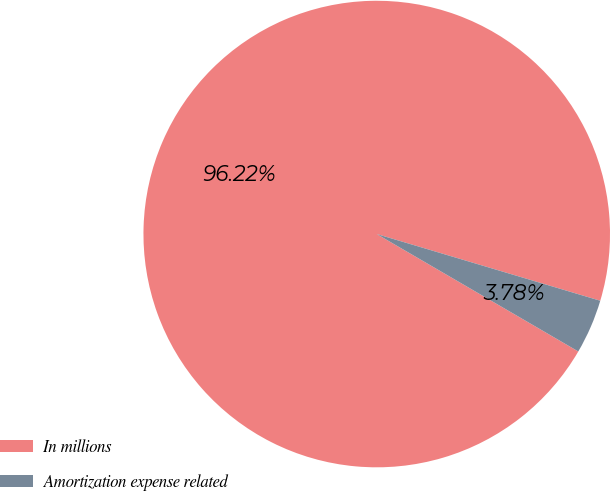Convert chart. <chart><loc_0><loc_0><loc_500><loc_500><pie_chart><fcel>In millions<fcel>Amortization expense related<nl><fcel>96.22%<fcel>3.78%<nl></chart> 